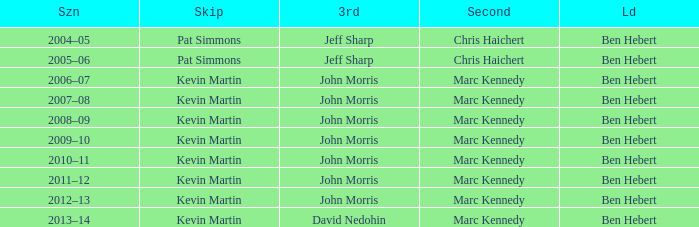What lead has the third David Nedohin? Ben Hebert. 